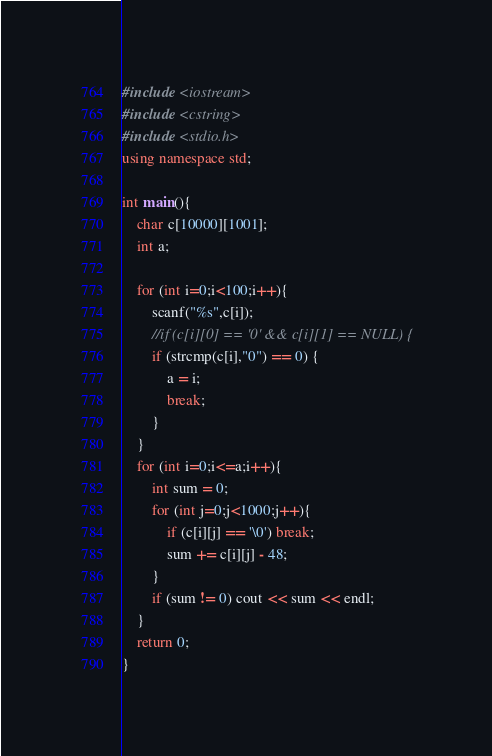<code> <loc_0><loc_0><loc_500><loc_500><_C++_>#include <iostream>
#include <cstring>
#include <stdio.h>
using namespace std;

int main(){
	char c[10000][1001];
	int a;
	
	for (int i=0;i<100;i++){
		scanf("%s",c[i]);
		//if (c[i][0] == '0' && c[i][1] == NULL) {
		if (strcmp(c[i],"0") == 0) {
			a = i;
			break; 
		}
	}
	for (int i=0;i<=a;i++){
		int sum = 0;
		for (int j=0;j<1000;j++){
			if (c[i][j] == '\0') break;
			sum += c[i][j] - 48;
		}
		if (sum != 0) cout << sum << endl;
	}
	return 0;
}</code> 